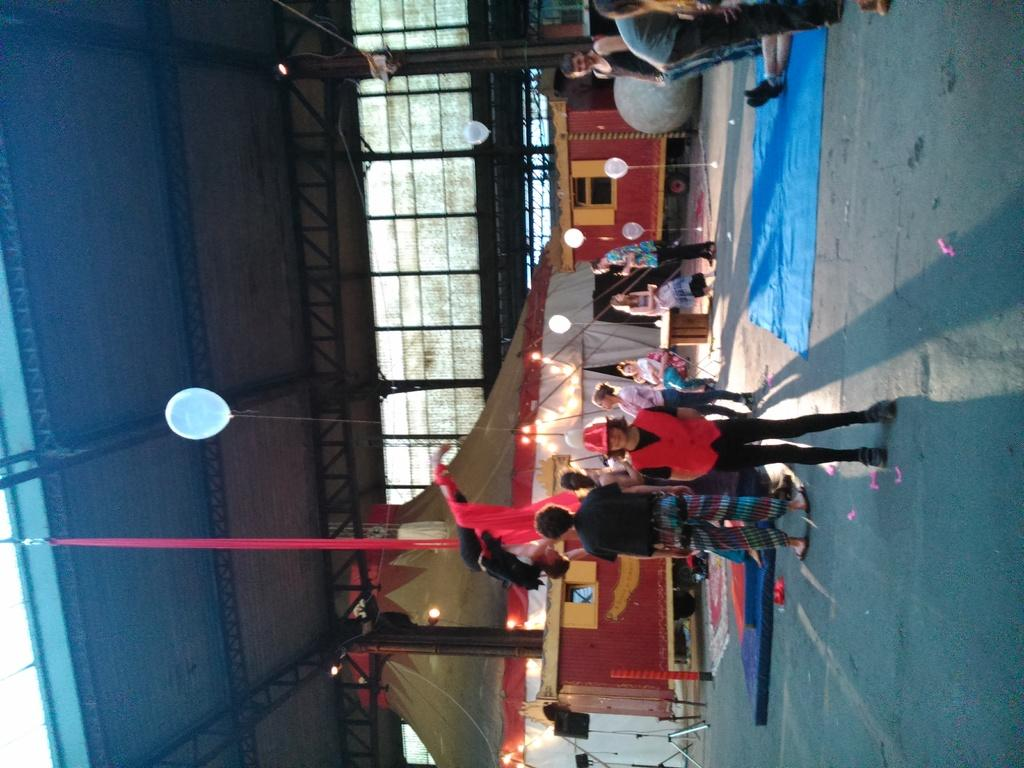How many people are present in the image? There are many people in the image. What structures can be seen in the image? There is a tent and a shed in the image. What else can be observed in the image besides people and structures? There are many objects in the image. Can you describe the condition of the snake in the image? There is no snake present in the image. 